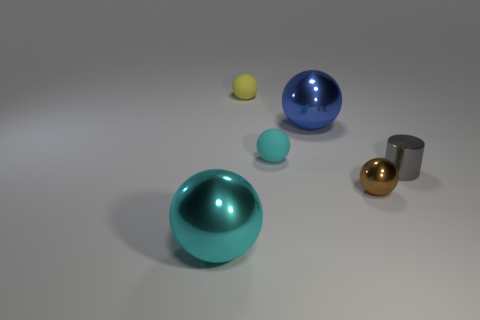Subtract all yellow cylinders. How many cyan spheres are left? 2 Subtract all small rubber spheres. How many spheres are left? 3 Add 1 tiny gray shiny objects. How many objects exist? 7 Subtract all cyan spheres. How many spheres are left? 3 Add 5 metal balls. How many metal balls are left? 8 Add 4 red blocks. How many red blocks exist? 4 Subtract 0 green balls. How many objects are left? 6 Subtract all balls. How many objects are left? 1 Subtract all red spheres. Subtract all purple blocks. How many spheres are left? 5 Subtract all large cyan shiny things. Subtract all cyan metallic things. How many objects are left? 4 